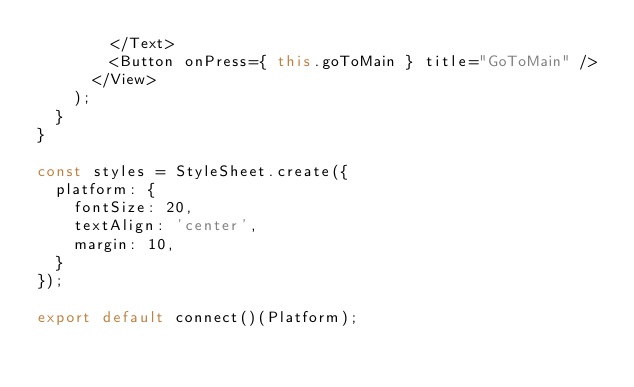<code> <loc_0><loc_0><loc_500><loc_500><_JavaScript_>        </Text>
        <Button onPress={ this.goToMain } title="GoToMain" />
      </View>
    );
  }
}

const styles = StyleSheet.create({
  platform: {
    fontSize: 20,
    textAlign: 'center',
    margin: 10,
  }
});

export default connect()(Platform);
</code> 